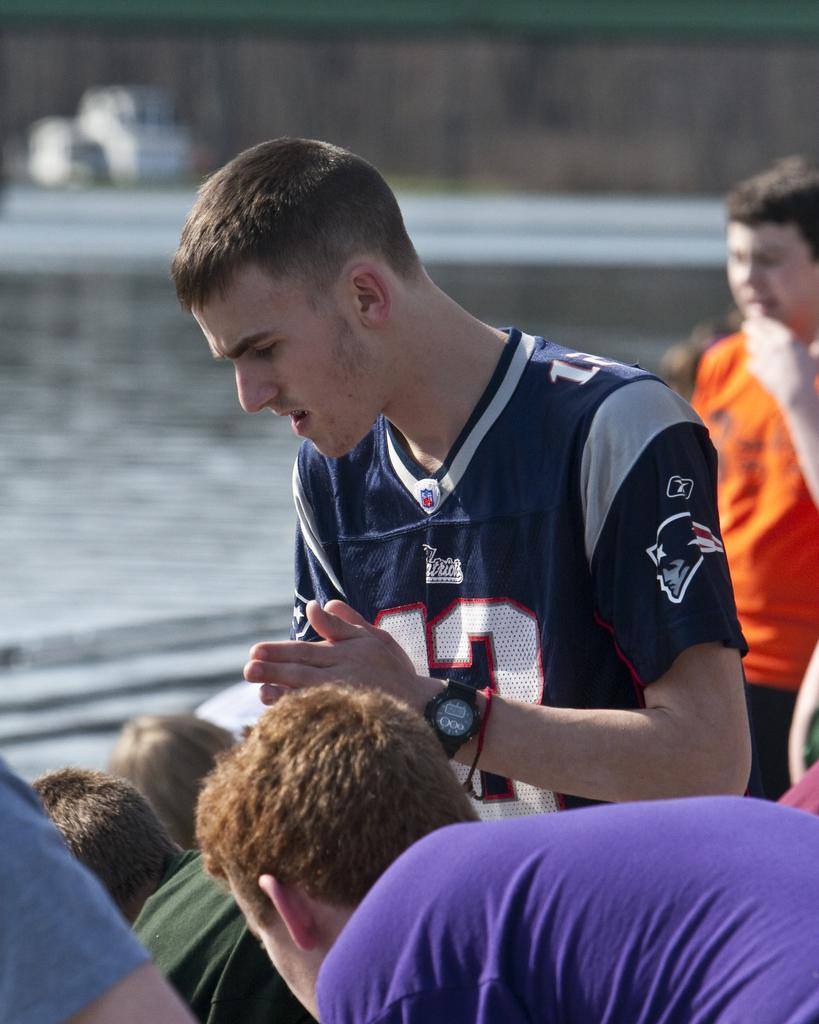<image>
Relay a brief, clear account of the picture shown. Young man in a Patriots Football shirt with number 13 on it with a group of boys. 